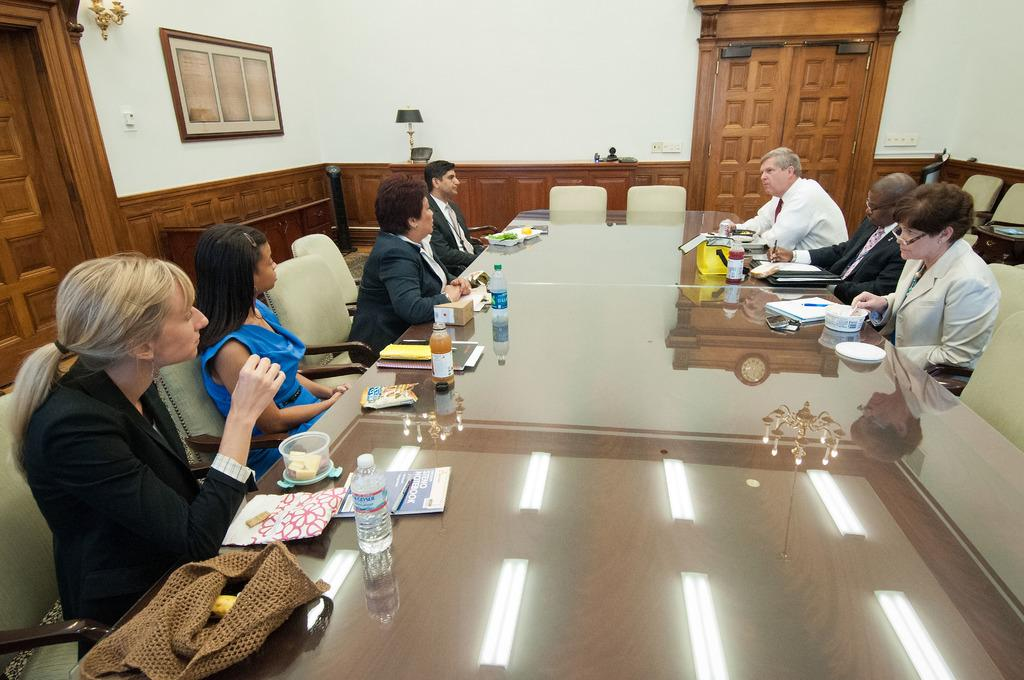What are the persons in the image doing? The persons in the image are sitting on chairs. What is on the table in the image? There are bottles and boxes on the table. What can be seen on the wall in the image? There is a frame on the wall. What architectural feature is present in the image? There is a door in the image. How many dogs can be seen in the image? There are no dogs present in the image. What type of eye is visible in the image? There is no eye visible in the image. 